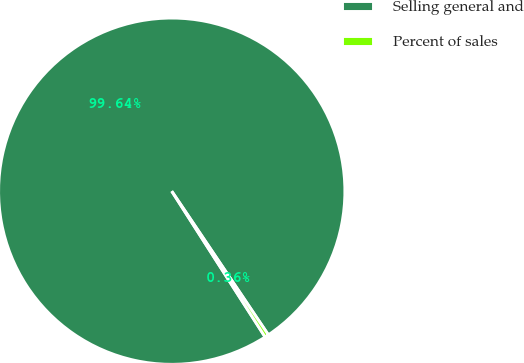<chart> <loc_0><loc_0><loc_500><loc_500><pie_chart><fcel>Selling general and<fcel>Percent of sales<nl><fcel>99.64%<fcel>0.36%<nl></chart> 